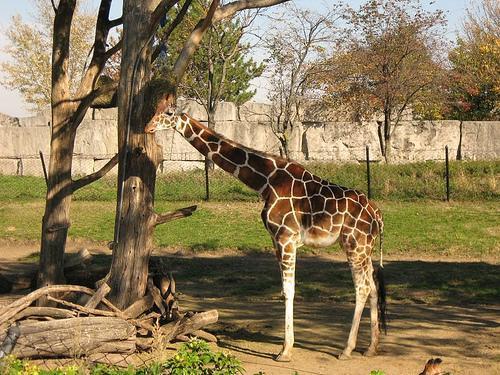How many giraffe are there?
Give a very brief answer. 1. How many animals are in this photo?
Give a very brief answer. 1. How many giraffes are visible?
Give a very brief answer. 1. 